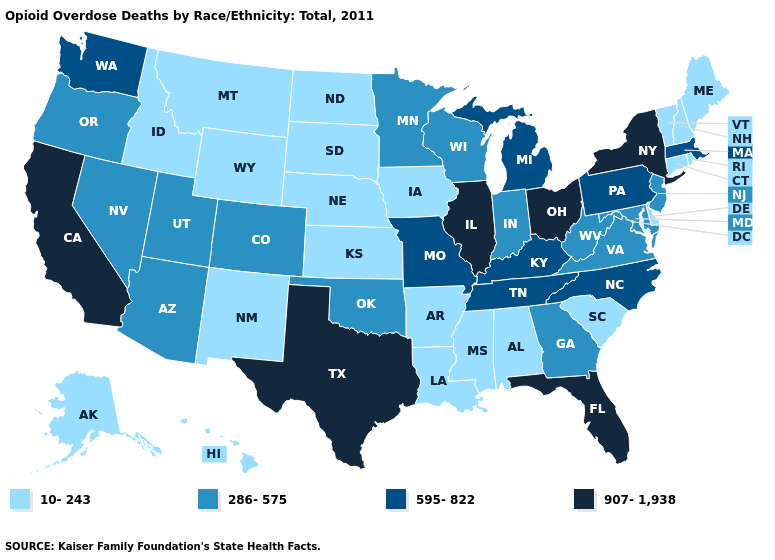What is the highest value in states that border Kansas?
Write a very short answer. 595-822. What is the value of Oklahoma?
Quick response, please. 286-575. How many symbols are there in the legend?
Quick response, please. 4. Does Wyoming have a lower value than Michigan?
Quick response, please. Yes. Which states have the lowest value in the MidWest?
Short answer required. Iowa, Kansas, Nebraska, North Dakota, South Dakota. What is the highest value in states that border Alabama?
Keep it brief. 907-1,938. Which states have the lowest value in the South?
Write a very short answer. Alabama, Arkansas, Delaware, Louisiana, Mississippi, South Carolina. Name the states that have a value in the range 907-1,938?
Be succinct. California, Florida, Illinois, New York, Ohio, Texas. Among the states that border Maryland , which have the highest value?
Quick response, please. Pennsylvania. What is the value of Illinois?
Concise answer only. 907-1,938. Does Texas have a lower value than Oregon?
Keep it brief. No. Name the states that have a value in the range 10-243?
Short answer required. Alabama, Alaska, Arkansas, Connecticut, Delaware, Hawaii, Idaho, Iowa, Kansas, Louisiana, Maine, Mississippi, Montana, Nebraska, New Hampshire, New Mexico, North Dakota, Rhode Island, South Carolina, South Dakota, Vermont, Wyoming. Name the states that have a value in the range 595-822?
Short answer required. Kentucky, Massachusetts, Michigan, Missouri, North Carolina, Pennsylvania, Tennessee, Washington. What is the value of Delaware?
Short answer required. 10-243. What is the lowest value in the USA?
Quick response, please. 10-243. 